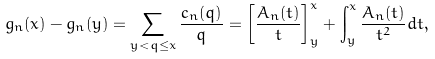Convert formula to latex. <formula><loc_0><loc_0><loc_500><loc_500>g _ { n } ( x ) - g _ { n } ( y ) = \sum _ { y < q \leq x } \frac { c _ { n } ( q ) } { q } = \left [ \frac { A _ { n } ( t ) } { t } \right ] _ { y } ^ { x } + \int _ { y } ^ { x } \frac { A _ { n } ( t ) } { t ^ { 2 } } d t ,</formula> 